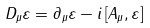Convert formula to latex. <formula><loc_0><loc_0><loc_500><loc_500>D _ { \mu } \varepsilon = \partial _ { \mu } \varepsilon - i \left [ A _ { \mu } , \varepsilon \right ]</formula> 